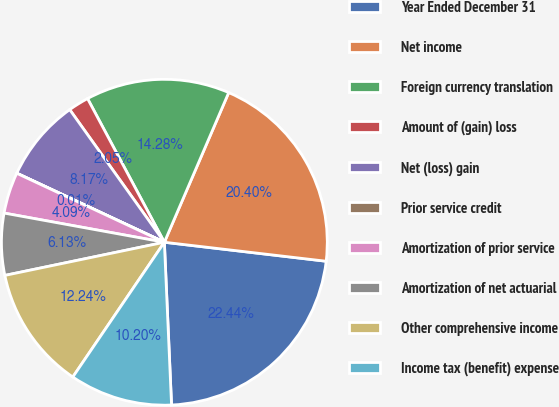<chart> <loc_0><loc_0><loc_500><loc_500><pie_chart><fcel>Year Ended December 31<fcel>Net income<fcel>Foreign currency translation<fcel>Amount of (gain) loss<fcel>Net (loss) gain<fcel>Prior service credit<fcel>Amortization of prior service<fcel>Amortization of net actuarial<fcel>Other comprehensive income<fcel>Income tax (benefit) expense<nl><fcel>22.44%<fcel>20.4%<fcel>14.28%<fcel>2.05%<fcel>8.17%<fcel>0.01%<fcel>4.09%<fcel>6.13%<fcel>12.24%<fcel>10.2%<nl></chart> 